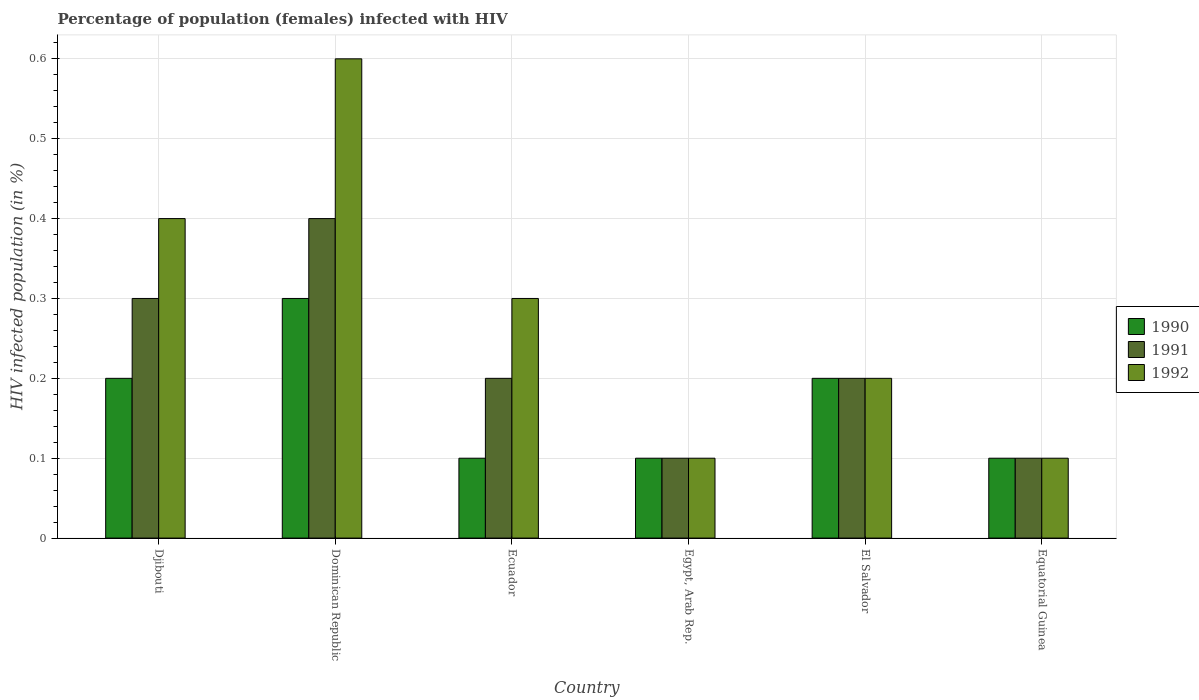How many different coloured bars are there?
Keep it short and to the point. 3. How many groups of bars are there?
Offer a very short reply. 6. Are the number of bars per tick equal to the number of legend labels?
Your answer should be very brief. Yes. How many bars are there on the 1st tick from the left?
Provide a short and direct response. 3. What is the label of the 1st group of bars from the left?
Keep it short and to the point. Djibouti. In how many cases, is the number of bars for a given country not equal to the number of legend labels?
Provide a short and direct response. 0. Across all countries, what is the maximum percentage of HIV infected female population in 1991?
Offer a very short reply. 0.4. Across all countries, what is the minimum percentage of HIV infected female population in 1991?
Ensure brevity in your answer.  0.1. In which country was the percentage of HIV infected female population in 1991 maximum?
Ensure brevity in your answer.  Dominican Republic. In which country was the percentage of HIV infected female population in 1992 minimum?
Ensure brevity in your answer.  Egypt, Arab Rep. What is the total percentage of HIV infected female population in 1990 in the graph?
Your response must be concise. 1. What is the difference between the percentage of HIV infected female population in 1991 in Egypt, Arab Rep. and the percentage of HIV infected female population in 1990 in Dominican Republic?
Your answer should be very brief. -0.2. What is the average percentage of HIV infected female population in 1992 per country?
Your response must be concise. 0.28. What is the ratio of the percentage of HIV infected female population in 1992 in Egypt, Arab Rep. to that in El Salvador?
Your answer should be compact. 0.5. What is the difference between the highest and the second highest percentage of HIV infected female population in 1992?
Your response must be concise. 0.2. In how many countries, is the percentage of HIV infected female population in 1990 greater than the average percentage of HIV infected female population in 1990 taken over all countries?
Offer a terse response. 3. Is the sum of the percentage of HIV infected female population in 1992 in Ecuador and El Salvador greater than the maximum percentage of HIV infected female population in 1990 across all countries?
Give a very brief answer. Yes. What does the 3rd bar from the left in Egypt, Arab Rep. represents?
Your response must be concise. 1992. What does the 2nd bar from the right in Dominican Republic represents?
Keep it short and to the point. 1991. How many bars are there?
Offer a very short reply. 18. How are the legend labels stacked?
Offer a very short reply. Vertical. What is the title of the graph?
Your answer should be compact. Percentage of population (females) infected with HIV. Does "1971" appear as one of the legend labels in the graph?
Make the answer very short. No. What is the label or title of the Y-axis?
Provide a short and direct response. HIV infected population (in %). What is the HIV infected population (in %) of 1990 in Djibouti?
Keep it short and to the point. 0.2. What is the HIV infected population (in %) of 1992 in Djibouti?
Offer a terse response. 0.4. What is the HIV infected population (in %) in 1990 in Dominican Republic?
Your answer should be compact. 0.3. What is the HIV infected population (in %) of 1992 in Dominican Republic?
Offer a very short reply. 0.6. What is the HIV infected population (in %) in 1992 in Ecuador?
Provide a succinct answer. 0.3. What is the HIV infected population (in %) in 1992 in El Salvador?
Keep it short and to the point. 0.2. What is the HIV infected population (in %) of 1990 in Equatorial Guinea?
Ensure brevity in your answer.  0.1. What is the HIV infected population (in %) in 1992 in Equatorial Guinea?
Make the answer very short. 0.1. Across all countries, what is the maximum HIV infected population (in %) in 1990?
Give a very brief answer. 0.3. Across all countries, what is the maximum HIV infected population (in %) of 1992?
Provide a succinct answer. 0.6. What is the total HIV infected population (in %) of 1991 in the graph?
Provide a short and direct response. 1.3. What is the difference between the HIV infected population (in %) in 1990 in Djibouti and that in Dominican Republic?
Keep it short and to the point. -0.1. What is the difference between the HIV infected population (in %) in 1990 in Djibouti and that in El Salvador?
Offer a very short reply. 0. What is the difference between the HIV infected population (in %) in 1991 in Djibouti and that in El Salvador?
Ensure brevity in your answer.  0.1. What is the difference between the HIV infected population (in %) of 1992 in Djibouti and that in El Salvador?
Provide a short and direct response. 0.2. What is the difference between the HIV infected population (in %) in 1990 in Djibouti and that in Equatorial Guinea?
Offer a very short reply. 0.1. What is the difference between the HIV infected population (in %) in 1991 in Djibouti and that in Equatorial Guinea?
Your answer should be very brief. 0.2. What is the difference between the HIV infected population (in %) in 1992 in Djibouti and that in Equatorial Guinea?
Offer a very short reply. 0.3. What is the difference between the HIV infected population (in %) in 1992 in Dominican Republic and that in Ecuador?
Your answer should be compact. 0.3. What is the difference between the HIV infected population (in %) of 1991 in Dominican Republic and that in Egypt, Arab Rep.?
Offer a very short reply. 0.3. What is the difference between the HIV infected population (in %) in 1992 in Dominican Republic and that in Egypt, Arab Rep.?
Ensure brevity in your answer.  0.5. What is the difference between the HIV infected population (in %) in 1992 in Dominican Republic and that in El Salvador?
Offer a very short reply. 0.4. What is the difference between the HIV infected population (in %) of 1990 in Dominican Republic and that in Equatorial Guinea?
Provide a succinct answer. 0.2. What is the difference between the HIV infected population (in %) of 1992 in Dominican Republic and that in Equatorial Guinea?
Offer a terse response. 0.5. What is the difference between the HIV infected population (in %) of 1990 in Ecuador and that in Egypt, Arab Rep.?
Make the answer very short. 0. What is the difference between the HIV infected population (in %) of 1991 in Ecuador and that in Egypt, Arab Rep.?
Provide a short and direct response. 0.1. What is the difference between the HIV infected population (in %) of 1992 in Ecuador and that in Egypt, Arab Rep.?
Your answer should be very brief. 0.2. What is the difference between the HIV infected population (in %) in 1990 in Ecuador and that in El Salvador?
Keep it short and to the point. -0.1. What is the difference between the HIV infected population (in %) in 1991 in Ecuador and that in El Salvador?
Offer a terse response. 0. What is the difference between the HIV infected population (in %) in 1990 in Egypt, Arab Rep. and that in El Salvador?
Keep it short and to the point. -0.1. What is the difference between the HIV infected population (in %) in 1991 in Egypt, Arab Rep. and that in El Salvador?
Make the answer very short. -0.1. What is the difference between the HIV infected population (in %) of 1990 in Egypt, Arab Rep. and that in Equatorial Guinea?
Offer a terse response. 0. What is the difference between the HIV infected population (in %) in 1991 in Egypt, Arab Rep. and that in Equatorial Guinea?
Provide a short and direct response. 0. What is the difference between the HIV infected population (in %) of 1992 in Egypt, Arab Rep. and that in Equatorial Guinea?
Keep it short and to the point. 0. What is the difference between the HIV infected population (in %) in 1990 in El Salvador and that in Equatorial Guinea?
Provide a succinct answer. 0.1. What is the difference between the HIV infected population (in %) of 1992 in El Salvador and that in Equatorial Guinea?
Your answer should be compact. 0.1. What is the difference between the HIV infected population (in %) of 1990 in Djibouti and the HIV infected population (in %) of 1992 in Dominican Republic?
Your answer should be compact. -0.4. What is the difference between the HIV infected population (in %) in 1991 in Djibouti and the HIV infected population (in %) in 1992 in Dominican Republic?
Offer a very short reply. -0.3. What is the difference between the HIV infected population (in %) in 1990 in Djibouti and the HIV infected population (in %) in 1992 in Ecuador?
Make the answer very short. -0.1. What is the difference between the HIV infected population (in %) of 1991 in Djibouti and the HIV infected population (in %) of 1992 in Ecuador?
Offer a terse response. 0. What is the difference between the HIV infected population (in %) in 1990 in Djibouti and the HIV infected population (in %) in 1991 in Egypt, Arab Rep.?
Your answer should be compact. 0.1. What is the difference between the HIV infected population (in %) of 1991 in Djibouti and the HIV infected population (in %) of 1992 in Egypt, Arab Rep.?
Keep it short and to the point. 0.2. What is the difference between the HIV infected population (in %) of 1990 in Djibouti and the HIV infected population (in %) of 1991 in El Salvador?
Your answer should be compact. 0. What is the difference between the HIV infected population (in %) of 1990 in Djibouti and the HIV infected population (in %) of 1991 in Equatorial Guinea?
Ensure brevity in your answer.  0.1. What is the difference between the HIV infected population (in %) of 1991 in Djibouti and the HIV infected population (in %) of 1992 in Equatorial Guinea?
Offer a very short reply. 0.2. What is the difference between the HIV infected population (in %) in 1990 in Dominican Republic and the HIV infected population (in %) in 1991 in Ecuador?
Keep it short and to the point. 0.1. What is the difference between the HIV infected population (in %) in 1990 in Dominican Republic and the HIV infected population (in %) in 1991 in El Salvador?
Your answer should be very brief. 0.1. What is the difference between the HIV infected population (in %) in 1991 in Dominican Republic and the HIV infected population (in %) in 1992 in Equatorial Guinea?
Your response must be concise. 0.3. What is the difference between the HIV infected population (in %) in 1990 in Ecuador and the HIV infected population (in %) in 1992 in Equatorial Guinea?
Provide a succinct answer. 0. What is the difference between the HIV infected population (in %) of 1991 in Ecuador and the HIV infected population (in %) of 1992 in Equatorial Guinea?
Your answer should be compact. 0.1. What is the difference between the HIV infected population (in %) in 1990 in Egypt, Arab Rep. and the HIV infected population (in %) in 1992 in El Salvador?
Offer a terse response. -0.1. What is the difference between the HIV infected population (in %) of 1990 in Egypt, Arab Rep. and the HIV infected population (in %) of 1992 in Equatorial Guinea?
Offer a terse response. 0. What is the difference between the HIV infected population (in %) of 1991 in Egypt, Arab Rep. and the HIV infected population (in %) of 1992 in Equatorial Guinea?
Your answer should be very brief. 0. What is the difference between the HIV infected population (in %) in 1990 in El Salvador and the HIV infected population (in %) in 1991 in Equatorial Guinea?
Ensure brevity in your answer.  0.1. What is the difference between the HIV infected population (in %) in 1990 in El Salvador and the HIV infected population (in %) in 1992 in Equatorial Guinea?
Keep it short and to the point. 0.1. What is the difference between the HIV infected population (in %) in 1991 in El Salvador and the HIV infected population (in %) in 1992 in Equatorial Guinea?
Offer a very short reply. 0.1. What is the average HIV infected population (in %) in 1991 per country?
Your response must be concise. 0.22. What is the average HIV infected population (in %) of 1992 per country?
Provide a short and direct response. 0.28. What is the difference between the HIV infected population (in %) of 1990 and HIV infected population (in %) of 1991 in Djibouti?
Your answer should be very brief. -0.1. What is the difference between the HIV infected population (in %) of 1990 and HIV infected population (in %) of 1992 in Djibouti?
Your answer should be compact. -0.2. What is the difference between the HIV infected population (in %) of 1990 and HIV infected population (in %) of 1991 in Dominican Republic?
Your response must be concise. -0.1. What is the difference between the HIV infected population (in %) of 1991 and HIV infected population (in %) of 1992 in Dominican Republic?
Give a very brief answer. -0.2. What is the difference between the HIV infected population (in %) of 1990 and HIV infected population (in %) of 1991 in Ecuador?
Provide a short and direct response. -0.1. What is the difference between the HIV infected population (in %) in 1991 and HIV infected population (in %) in 1992 in Ecuador?
Your answer should be very brief. -0.1. What is the difference between the HIV infected population (in %) in 1990 and HIV infected population (in %) in 1992 in Egypt, Arab Rep.?
Keep it short and to the point. 0. What is the difference between the HIV infected population (in %) in 1990 and HIV infected population (in %) in 1991 in El Salvador?
Give a very brief answer. 0. What is the difference between the HIV infected population (in %) in 1990 and HIV infected population (in %) in 1992 in El Salvador?
Provide a short and direct response. 0. What is the difference between the HIV infected population (in %) in 1990 and HIV infected population (in %) in 1992 in Equatorial Guinea?
Give a very brief answer. 0. What is the difference between the HIV infected population (in %) in 1991 and HIV infected population (in %) in 1992 in Equatorial Guinea?
Provide a succinct answer. 0. What is the ratio of the HIV infected population (in %) in 1991 in Djibouti to that in Dominican Republic?
Provide a short and direct response. 0.75. What is the ratio of the HIV infected population (in %) of 1992 in Djibouti to that in Dominican Republic?
Provide a short and direct response. 0.67. What is the ratio of the HIV infected population (in %) of 1990 in Djibouti to that in Ecuador?
Your answer should be compact. 2. What is the ratio of the HIV infected population (in %) of 1991 in Djibouti to that in Egypt, Arab Rep.?
Your answer should be compact. 3. What is the ratio of the HIV infected population (in %) of 1992 in Djibouti to that in Egypt, Arab Rep.?
Give a very brief answer. 4. What is the ratio of the HIV infected population (in %) of 1990 in Djibouti to that in El Salvador?
Give a very brief answer. 1. What is the ratio of the HIV infected population (in %) in 1991 in Djibouti to that in El Salvador?
Your response must be concise. 1.5. What is the ratio of the HIV infected population (in %) of 1992 in Djibouti to that in El Salvador?
Offer a terse response. 2. What is the ratio of the HIV infected population (in %) of 1990 in Djibouti to that in Equatorial Guinea?
Your response must be concise. 2. What is the ratio of the HIV infected population (in %) of 1992 in Djibouti to that in Equatorial Guinea?
Provide a succinct answer. 4. What is the ratio of the HIV infected population (in %) in 1990 in Dominican Republic to that in El Salvador?
Ensure brevity in your answer.  1.5. What is the ratio of the HIV infected population (in %) in 1991 in Dominican Republic to that in Equatorial Guinea?
Offer a terse response. 4. What is the ratio of the HIV infected population (in %) in 1992 in Dominican Republic to that in Equatorial Guinea?
Offer a very short reply. 6. What is the ratio of the HIV infected population (in %) in 1992 in Ecuador to that in Egypt, Arab Rep.?
Provide a short and direct response. 3. What is the ratio of the HIV infected population (in %) in 1990 in Ecuador to that in El Salvador?
Your answer should be very brief. 0.5. What is the ratio of the HIV infected population (in %) in 1991 in Ecuador to that in El Salvador?
Give a very brief answer. 1. What is the ratio of the HIV infected population (in %) of 1992 in Ecuador to that in El Salvador?
Keep it short and to the point. 1.5. What is the ratio of the HIV infected population (in %) of 1992 in Egypt, Arab Rep. to that in El Salvador?
Your answer should be compact. 0.5. What is the ratio of the HIV infected population (in %) in 1990 in Egypt, Arab Rep. to that in Equatorial Guinea?
Make the answer very short. 1. What is the ratio of the HIV infected population (in %) of 1990 in El Salvador to that in Equatorial Guinea?
Ensure brevity in your answer.  2. What is the ratio of the HIV infected population (in %) of 1991 in El Salvador to that in Equatorial Guinea?
Your response must be concise. 2. What is the ratio of the HIV infected population (in %) in 1992 in El Salvador to that in Equatorial Guinea?
Make the answer very short. 2. What is the difference between the highest and the second highest HIV infected population (in %) in 1990?
Your response must be concise. 0.1. What is the difference between the highest and the second highest HIV infected population (in %) in 1991?
Make the answer very short. 0.1. What is the difference between the highest and the second highest HIV infected population (in %) of 1992?
Your answer should be compact. 0.2. What is the difference between the highest and the lowest HIV infected population (in %) of 1990?
Ensure brevity in your answer.  0.2. 